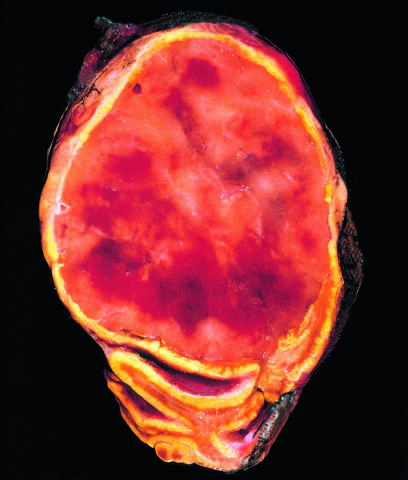how are granules containing catecholamine?
Answer the question using a single word or phrase. Not visible in this preparation 